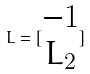<formula> <loc_0><loc_0><loc_500><loc_500>L = [ \begin{matrix} - 1 \\ L _ { 2 } \end{matrix} ]</formula> 